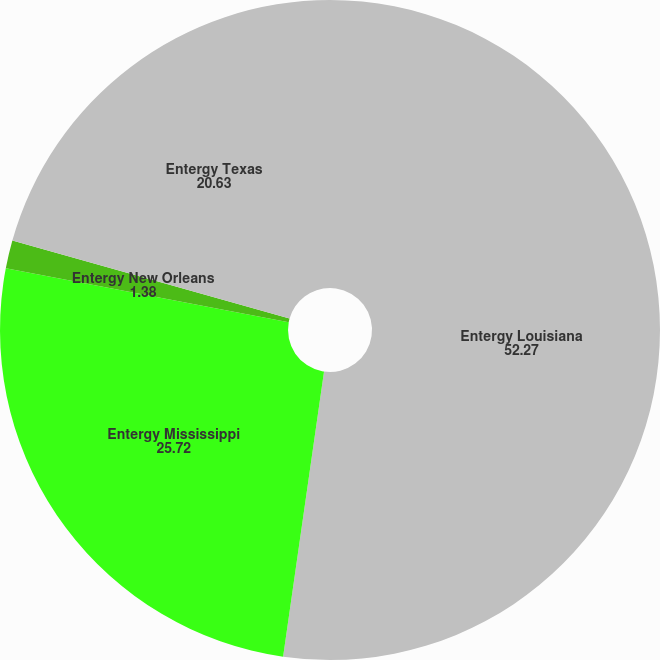Convert chart. <chart><loc_0><loc_0><loc_500><loc_500><pie_chart><fcel>Entergy Louisiana<fcel>Entergy Mississippi<fcel>Entergy New Orleans<fcel>Entergy Texas<nl><fcel>52.27%<fcel>25.72%<fcel>1.38%<fcel>20.63%<nl></chart> 